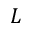<formula> <loc_0><loc_0><loc_500><loc_500>L</formula> 